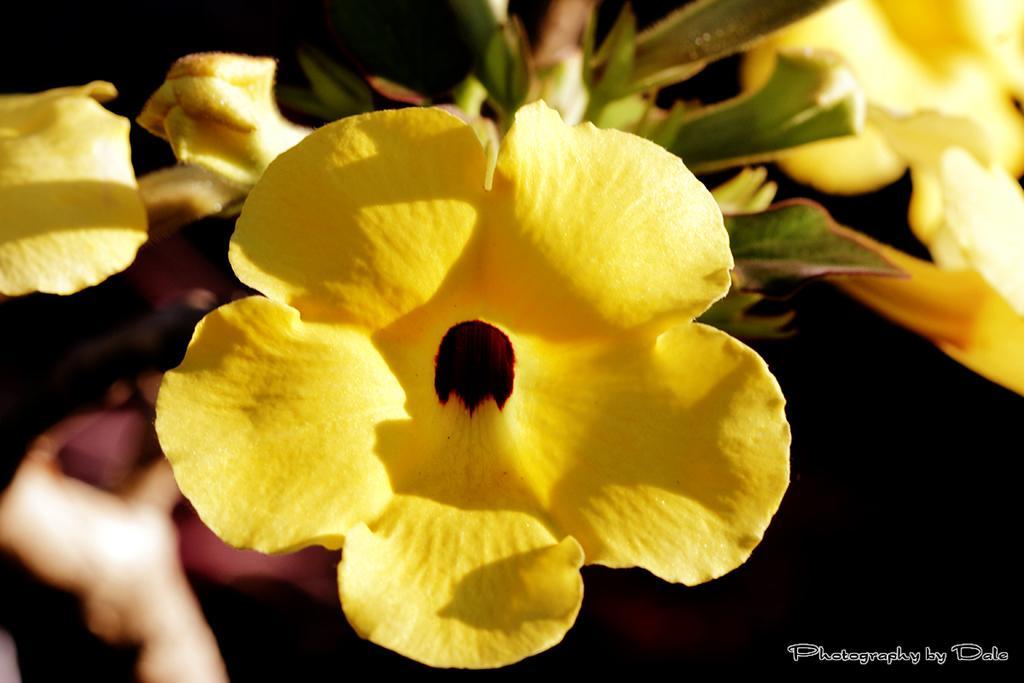Could you give a brief overview of what you see in this image? In this image we can see some flowers which are in yellow color and the background is dark and we can see some text on the image. 